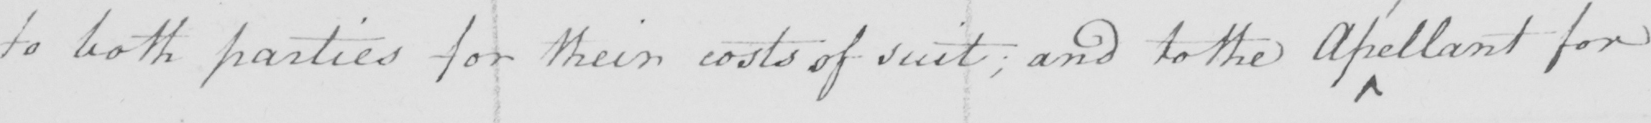Can you read and transcribe this handwriting? to both parties for their costs of suit ; and to the apellant for 